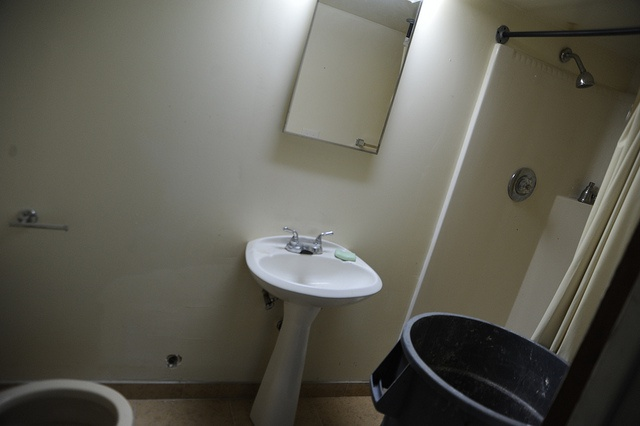Describe the objects in this image and their specific colors. I can see sink in black, darkgray, and lightgray tones and toilet in black and gray tones in this image. 